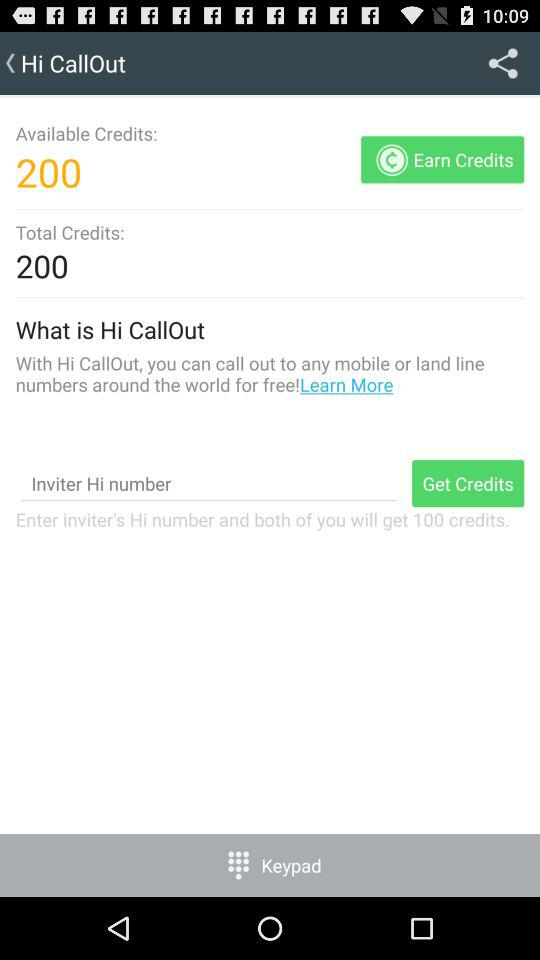How many credits do I have available?
Answer the question using a single word or phrase. 200 